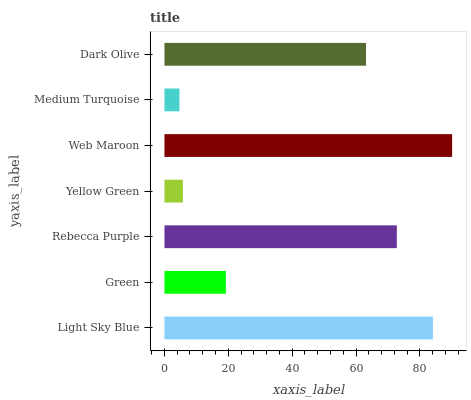Is Medium Turquoise the minimum?
Answer yes or no. Yes. Is Web Maroon the maximum?
Answer yes or no. Yes. Is Green the minimum?
Answer yes or no. No. Is Green the maximum?
Answer yes or no. No. Is Light Sky Blue greater than Green?
Answer yes or no. Yes. Is Green less than Light Sky Blue?
Answer yes or no. Yes. Is Green greater than Light Sky Blue?
Answer yes or no. No. Is Light Sky Blue less than Green?
Answer yes or no. No. Is Dark Olive the high median?
Answer yes or no. Yes. Is Dark Olive the low median?
Answer yes or no. Yes. Is Yellow Green the high median?
Answer yes or no. No. Is Medium Turquoise the low median?
Answer yes or no. No. 